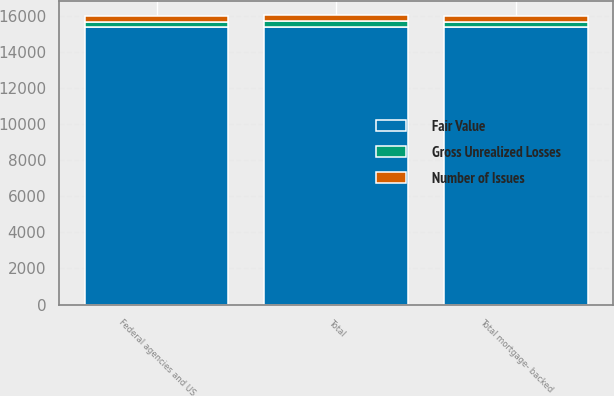<chart> <loc_0><loc_0><loc_500><loc_500><stacked_bar_chart><ecel><fcel>Federal agencies and US<fcel>Total mortgage- backed<fcel>Total<nl><fcel>Number of Issues<fcel>323<fcel>327<fcel>328<nl><fcel>Fair Value<fcel>15387<fcel>15395<fcel>15403<nl><fcel>Gross Unrealized Losses<fcel>292<fcel>292<fcel>292<nl></chart> 